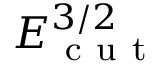<formula> <loc_0><loc_0><loc_500><loc_500>E _ { c u t } ^ { 3 / 2 }</formula> 